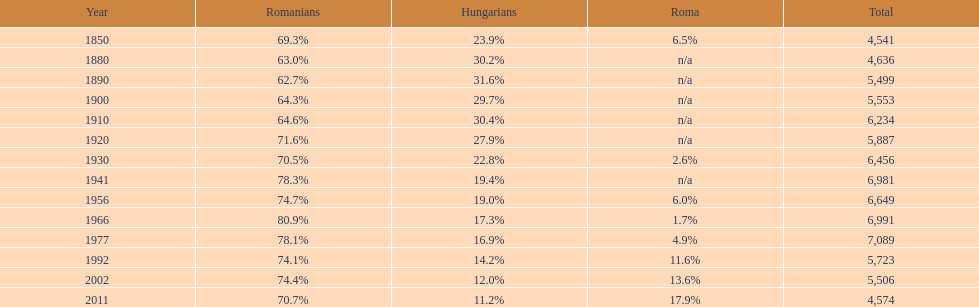In what year was there the largest percentage of hungarians? 1890. 